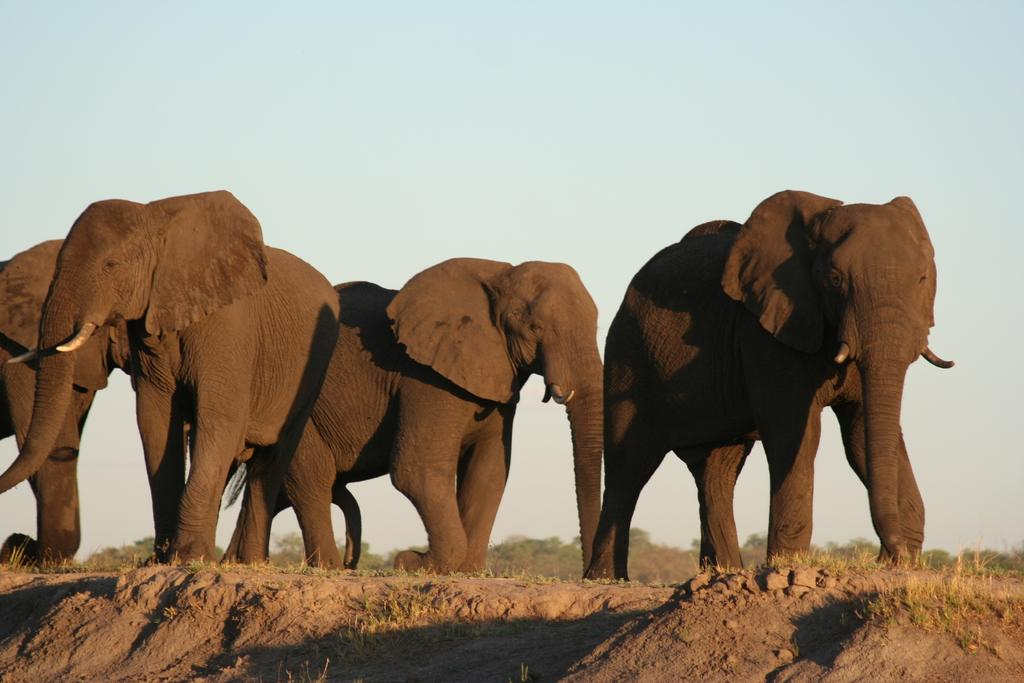How many elephants are present in the image? There are four elephants in the image. What are the elephants doing in the image? The elephants are walking. What type of terrain is visible at the bottom of the image? There is soil at the bottom of the image. What can be seen in the background of the image? There are trees in the background of the image. What is visible at the top of the image? The sky is visible at the top of the image. What type of pleasure can be seen being celebrated by the elephants in the image? There is no indication of any celebration or pleasure in the image; the elephants are simply walking. Is there a birthday cake visible in the image? No, there is no birthday cake present in the image. 